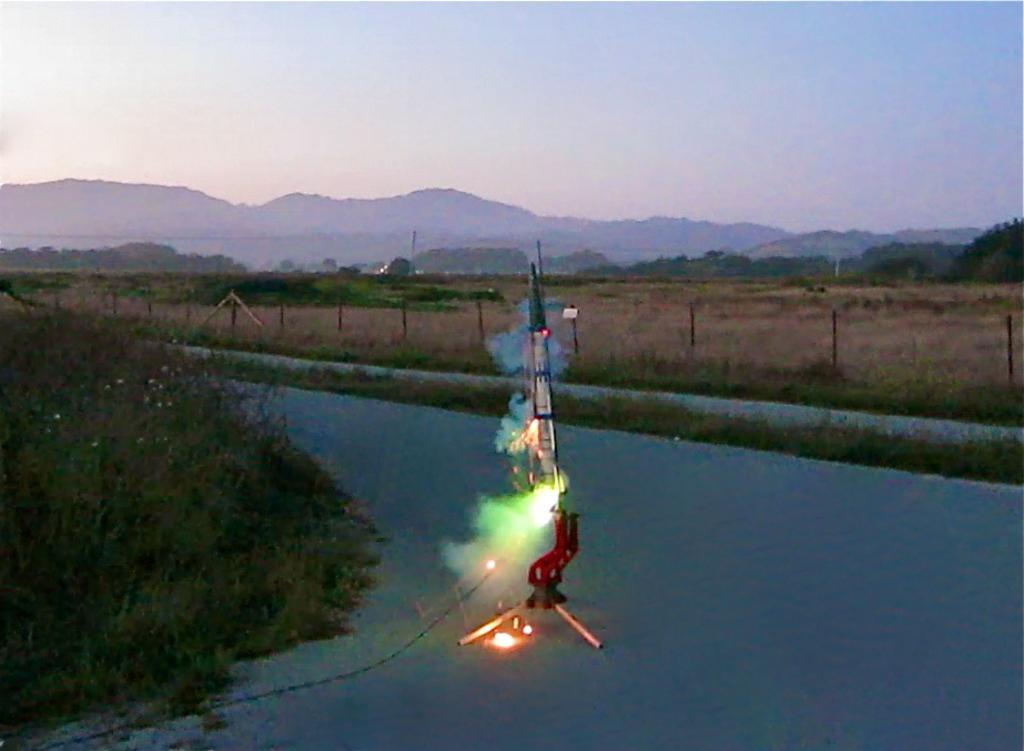Please provide a concise description of this image. In this image there is a rocket on the road. On the left side of the image there are trees and in the background there are a few rods, trees, mountains and the sky. 